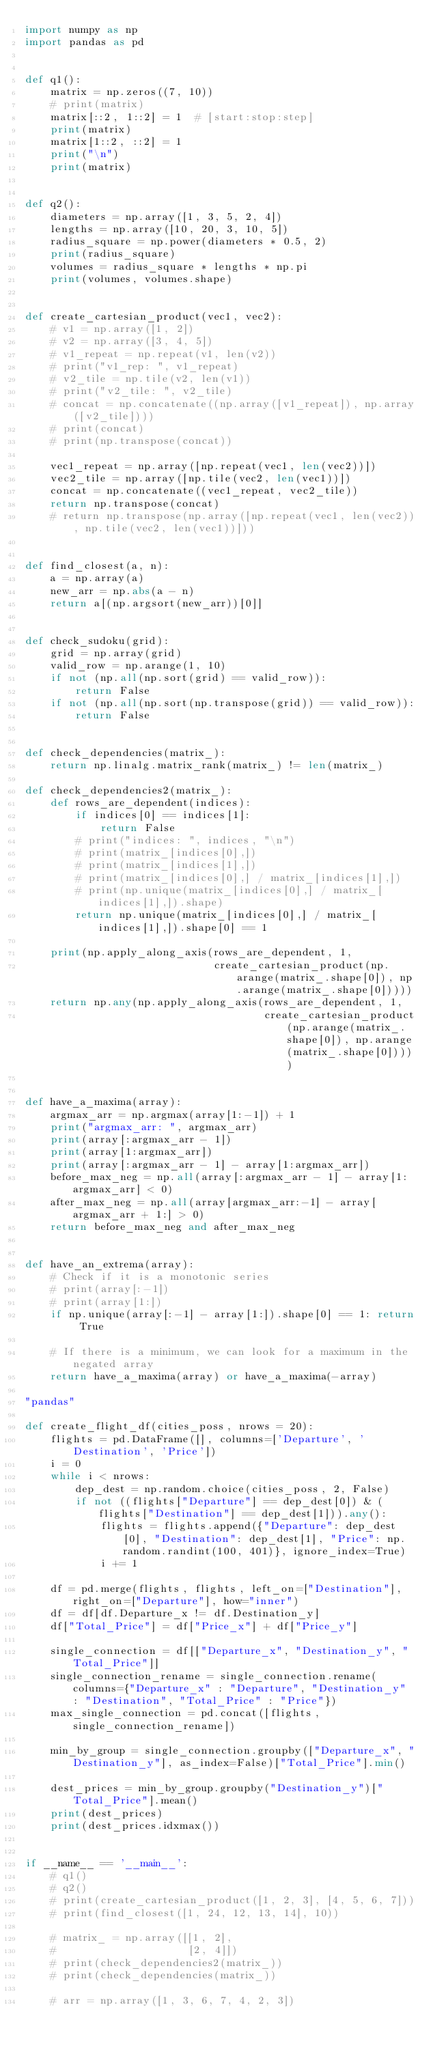Convert code to text. <code><loc_0><loc_0><loc_500><loc_500><_Python_>import numpy as np
import pandas as pd


def q1():
    matrix = np.zeros((7, 10))
    # print(matrix)
    matrix[::2, 1::2] = 1  # [start:stop:step]
    print(matrix)
    matrix[1::2, ::2] = 1
    print("\n")
    print(matrix)


def q2():
    diameters = np.array([1, 3, 5, 2, 4])
    lengths = np.array([10, 20, 3, 10, 5])
    radius_square = np.power(diameters * 0.5, 2)
    print(radius_square)
    volumes = radius_square * lengths * np.pi
    print(volumes, volumes.shape)


def create_cartesian_product(vec1, vec2):
    # v1 = np.array([1, 2])
    # v2 = np.array([3, 4, 5])
    # v1_repeat = np.repeat(v1, len(v2))
    # print("v1_rep: ", v1_repeat)
    # v2_tile = np.tile(v2, len(v1))
    # print("v2_tile: ", v2_tile)
    # concat = np.concatenate((np.array([v1_repeat]), np.array([v2_tile])))
    # print(concat)
    # print(np.transpose(concat))

    vec1_repeat = np.array([np.repeat(vec1, len(vec2))])
    vec2_tile = np.array([np.tile(vec2, len(vec1))])
    concat = np.concatenate((vec1_repeat, vec2_tile))
    return np.transpose(concat)
    # return np.transpose(np.array([np.repeat(vec1, len(vec2)), np.tile(vec2, len(vec1))]))


def find_closest(a, n):
    a = np.array(a)
    new_arr = np.abs(a - n)
    return a[(np.argsort(new_arr))[0]]


def check_sudoku(grid):
    grid = np.array(grid)
    valid_row = np.arange(1, 10)
    if not (np.all(np.sort(grid) == valid_row)):
        return False
    if not (np.all(np.sort(np.transpose(grid)) == valid_row)):
        return False


def check_dependencies(matrix_):
    return np.linalg.matrix_rank(matrix_) != len(matrix_)

def check_dependencies2(matrix_):
    def rows_are_dependent(indices):
        if indices[0] == indices[1]:
            return False
        # print("indices: ", indices, "\n")
        # print(matrix_[indices[0],])
        # print(matrix_[indices[1],])
        # print(matrix_[indices[0],] / matrix_[indices[1],])
        # print(np.unique(matrix_[indices[0],] / matrix_[indices[1],]).shape)
        return np.unique(matrix_[indices[0],] / matrix_[indices[1],]).shape[0] == 1

    print(np.apply_along_axis(rows_are_dependent, 1,
                              create_cartesian_product(np.arange(matrix_.shape[0]), np.arange(matrix_.shape[0]))))
    return np.any(np.apply_along_axis(rows_are_dependent, 1,
                                      create_cartesian_product(np.arange(matrix_.shape[0]), np.arange(matrix_.shape[0]))))


def have_a_maxima(array):
    argmax_arr = np.argmax(array[1:-1]) + 1
    print("argmax_arr: ", argmax_arr)
    print(array[:argmax_arr - 1])
    print(array[1:argmax_arr])
    print(array[:argmax_arr - 1] - array[1:argmax_arr])
    before_max_neg = np.all(array[:argmax_arr - 1] - array[1:argmax_arr] < 0)
    after_max_neg = np.all(array[argmax_arr:-1] - array[argmax_arr + 1:] > 0)
    return before_max_neg and after_max_neg


def have_an_extrema(array):
    # Check if it is a monotonic series
    # print(array[:-1])
    # print(array[1:])
    if np.unique(array[:-1] - array[1:]).shape[0] == 1: return True

    # If there is a minimum, we can look for a maximum in the negated array
    return have_a_maxima(array) or have_a_maxima(-array)

"pandas"

def create_flight_df(cities_poss, nrows = 20):
    flights = pd.DataFrame([], columns=['Departure', 'Destination', 'Price'])
    i = 0
    while i < nrows:
        dep_dest = np.random.choice(cities_poss, 2, False)
        if not ((flights["Departure"] == dep_dest[0]) & (flights["Destination"] == dep_dest[1])).any():
            flights = flights.append({"Departure": dep_dest[0], "Destination": dep_dest[1], "Price": np.random.randint(100, 401)}, ignore_index=True)
            i += 1

    df = pd.merge(flights, flights, left_on=["Destination"], right_on=["Departure"], how="inner")
    df = df[df.Departure_x != df.Destination_y]
    df["Total_Price"] = df["Price_x"] + df["Price_y"]

    single_connection = df[["Departure_x", "Destination_y", "Total_Price"]]
    single_connection_rename = single_connection.rename(columns={"Departure_x" : "Departure", "Destination_y" : "Destination", "Total_Price" : "Price"})
    max_single_connection = pd.concat([flights, single_connection_rename])

    min_by_group = single_connection.groupby(["Departure_x", "Destination_y"], as_index=False)["Total_Price"].min()

    dest_prices = min_by_group.groupby("Destination_y")["Total_Price"].mean()
    print(dest_prices)
    print(dest_prices.idxmax())


if __name__ == '__main__':
    # q1()
    # q2()
    # print(create_cartesian_product([1, 2, 3], [4, 5, 6, 7]))
    # print(find_closest([1, 24, 12, 13, 14], 10))

    # matrix_ = np.array([[1, 2],
    #                     [2, 4]])
    # print(check_dependencies2(matrix_))
    # print(check_dependencies(matrix_))

    # arr = np.array([1, 3, 6, 7, 4, 2, 3])</code> 